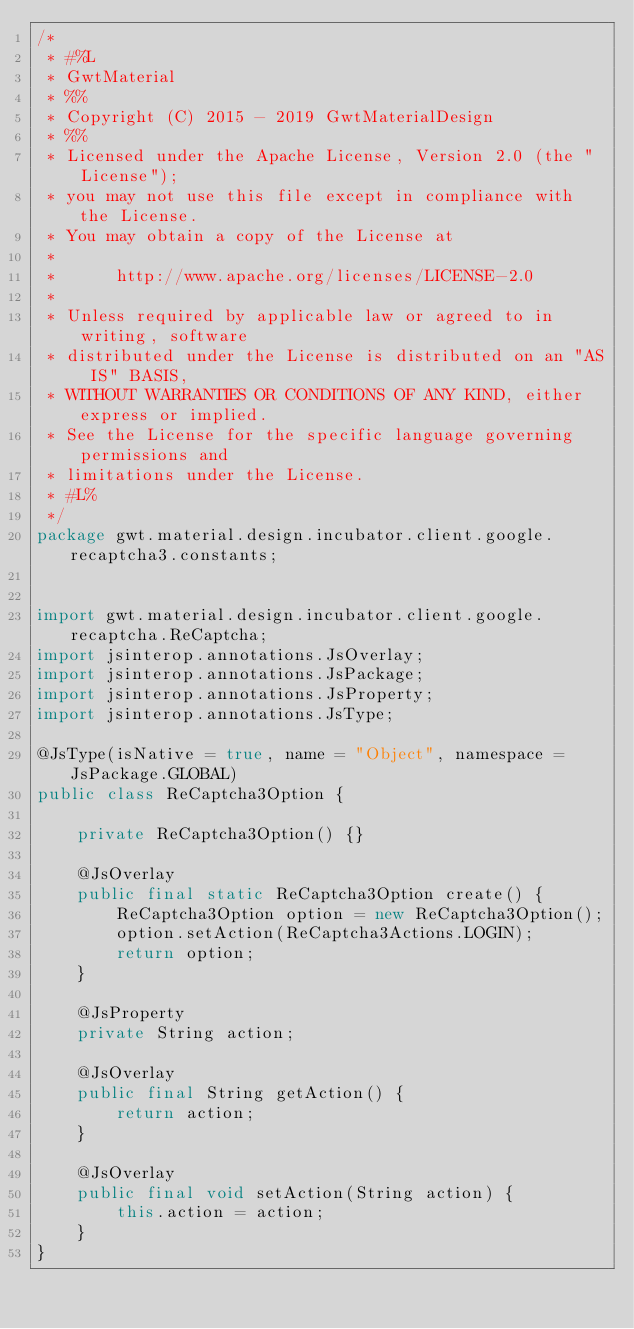<code> <loc_0><loc_0><loc_500><loc_500><_Java_>/*
 * #%L
 * GwtMaterial
 * %%
 * Copyright (C) 2015 - 2019 GwtMaterialDesign
 * %%
 * Licensed under the Apache License, Version 2.0 (the "License");
 * you may not use this file except in compliance with the License.
 * You may obtain a copy of the License at
 * 
 *      http://www.apache.org/licenses/LICENSE-2.0
 * 
 * Unless required by applicable law or agreed to in writing, software
 * distributed under the License is distributed on an "AS IS" BASIS,
 * WITHOUT WARRANTIES OR CONDITIONS OF ANY KIND, either express or implied.
 * See the License for the specific language governing permissions and
 * limitations under the License.
 * #L%
 */
package gwt.material.design.incubator.client.google.recaptcha3.constants;


import gwt.material.design.incubator.client.google.recaptcha.ReCaptcha;
import jsinterop.annotations.JsOverlay;
import jsinterop.annotations.JsPackage;
import jsinterop.annotations.JsProperty;
import jsinterop.annotations.JsType;

@JsType(isNative = true, name = "Object", namespace = JsPackage.GLOBAL)
public class ReCaptcha3Option {

    private ReCaptcha3Option() {}

    @JsOverlay
    public final static ReCaptcha3Option create() {
        ReCaptcha3Option option = new ReCaptcha3Option();
        option.setAction(ReCaptcha3Actions.LOGIN);
        return option;
    }

    @JsProperty
    private String action;

    @JsOverlay
    public final String getAction() {
        return action;
    }

    @JsOverlay
    public final void setAction(String action) {
        this.action = action;
    }
}
</code> 